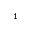<formula> <loc_0><loc_0><loc_500><loc_500>_ { 1 }</formula> 